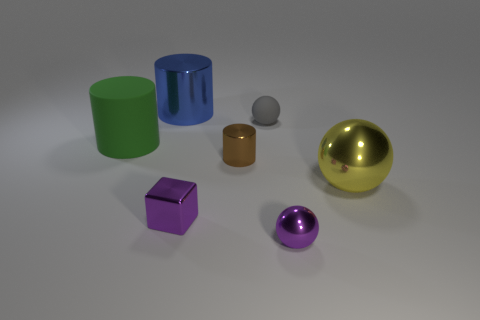Is there a cyan thing of the same size as the metal cube?
Offer a terse response. No. What is the color of the small cube?
Make the answer very short. Purple. The metallic ball to the right of the tiny purple ball in front of the green rubber cylinder is what color?
Provide a succinct answer. Yellow. There is a purple object right of the tiny object left of the brown shiny object on the left side of the tiny gray thing; what is its shape?
Provide a succinct answer. Sphere. What number of tiny gray objects have the same material as the tiny brown cylinder?
Provide a succinct answer. 0. There is a small shiny thing on the right side of the tiny rubber object; how many things are behind it?
Provide a short and direct response. 6. What number of tiny yellow shiny cylinders are there?
Make the answer very short. 0. Does the tiny cylinder have the same material as the small sphere in front of the small gray sphere?
Offer a very short reply. Yes. There is a sphere to the left of the purple shiny sphere; is it the same color as the matte cylinder?
Provide a succinct answer. No. There is a large thing that is both to the left of the rubber ball and to the right of the green matte cylinder; what is it made of?
Your response must be concise. Metal. 